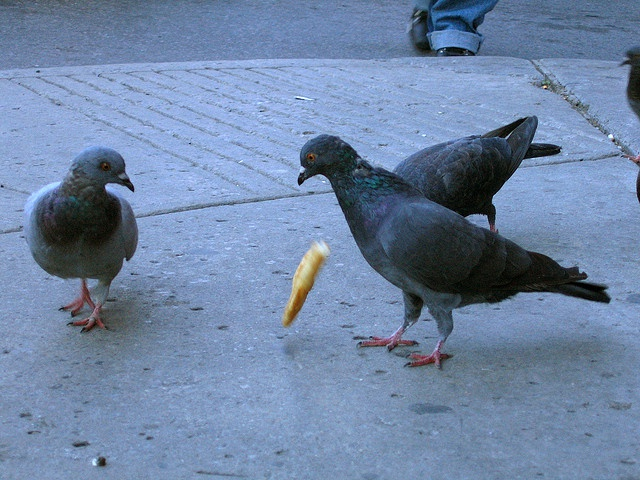Describe the objects in this image and their specific colors. I can see bird in gray, black, blue, and navy tones, bird in gray, black, and blue tones, bird in gray, black, blue, and navy tones, people in gray, black, navy, and blue tones, and pizza in gray, beige, tan, olive, and maroon tones in this image. 